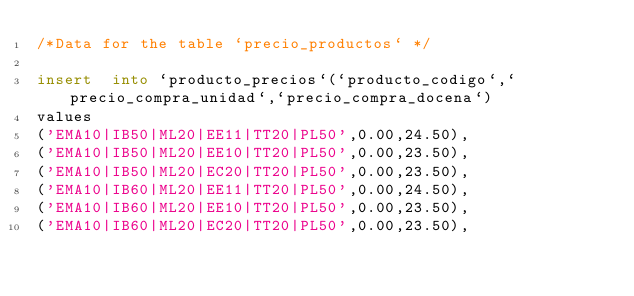Convert code to text. <code><loc_0><loc_0><loc_500><loc_500><_SQL_>/*Data for the table `precio_productos` */

insert  into `producto_precios`(`producto_codigo`,`precio_compra_unidad`,`precio_compra_docena`)
values
('EMA10|IB50|ML20|EE11|TT20|PL50',0.00,24.50),
('EMA10|IB50|ML20|EE10|TT20|PL50',0.00,23.50),
('EMA10|IB50|ML20|EC20|TT20|PL50',0.00,23.50),
('EMA10|IB60|ML20|EE11|TT20|PL50',0.00,24.50),
('EMA10|IB60|ML20|EE10|TT20|PL50',0.00,23.50),
('EMA10|IB60|ML20|EC20|TT20|PL50',0.00,23.50),</code> 